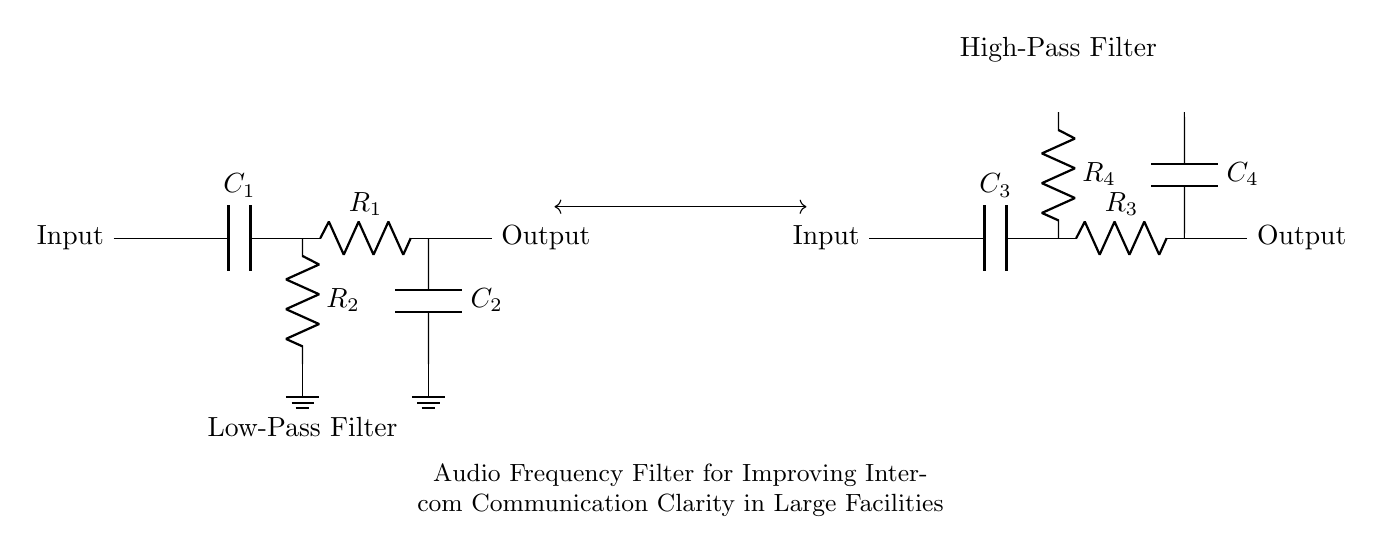What type of filter is depicted in the circuit? The circuit diagram shows two filters: a low-pass filter and a high-pass filter, arranged in a way that allows certain frequencies to pass through while attenuating others. This specific type of arrangement is used for improving audio frequency clarity.
Answer: Low-pass and high-pass What components are in the low-pass filter? The low-pass filter consists of a capacitor labeled C1 and a resistor labeled R1, along with a resistor R2 that connects to ground, forming a typical RC filter configuration.
Answer: C1, R1, R2 What does the R4 resistor do in the high-pass filter? The R4 resistor, in conjunction with the capacitor C4, works to allow higher frequencies to pass while blocking lower frequencies, thus tailoring the audio output for better clarity in intercom communications.
Answer: Allows higher frequencies How many capacitors are present in this circuit? There are a total of four capacitors labeled C1, C2, C3, and C4 used in both the low-pass and high-pass filters in the circuit diagram.
Answer: Four What happens to frequencies below the cutoff frequency in the low-pass filter? Frequencies below the cutoff frequency in the low-pass filter are allowed to pass through with minimal attenuation, making them clearer in the audio output, while frequencies above this point are significantly attenuated.
Answer: Allowed to pass What is the function of the C2 capacitor in the low-pass filter? The C2 capacitor acts as a coupling capacitor, which helps filter out high-frequency noise while allowing the desired audio frequency range to pass, enhancing communication clarity in intercom systems.
Answer: Filters out high frequencies 